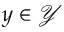Convert formula to latex. <formula><loc_0><loc_0><loc_500><loc_500>y \in \mathcal { Y }</formula> 